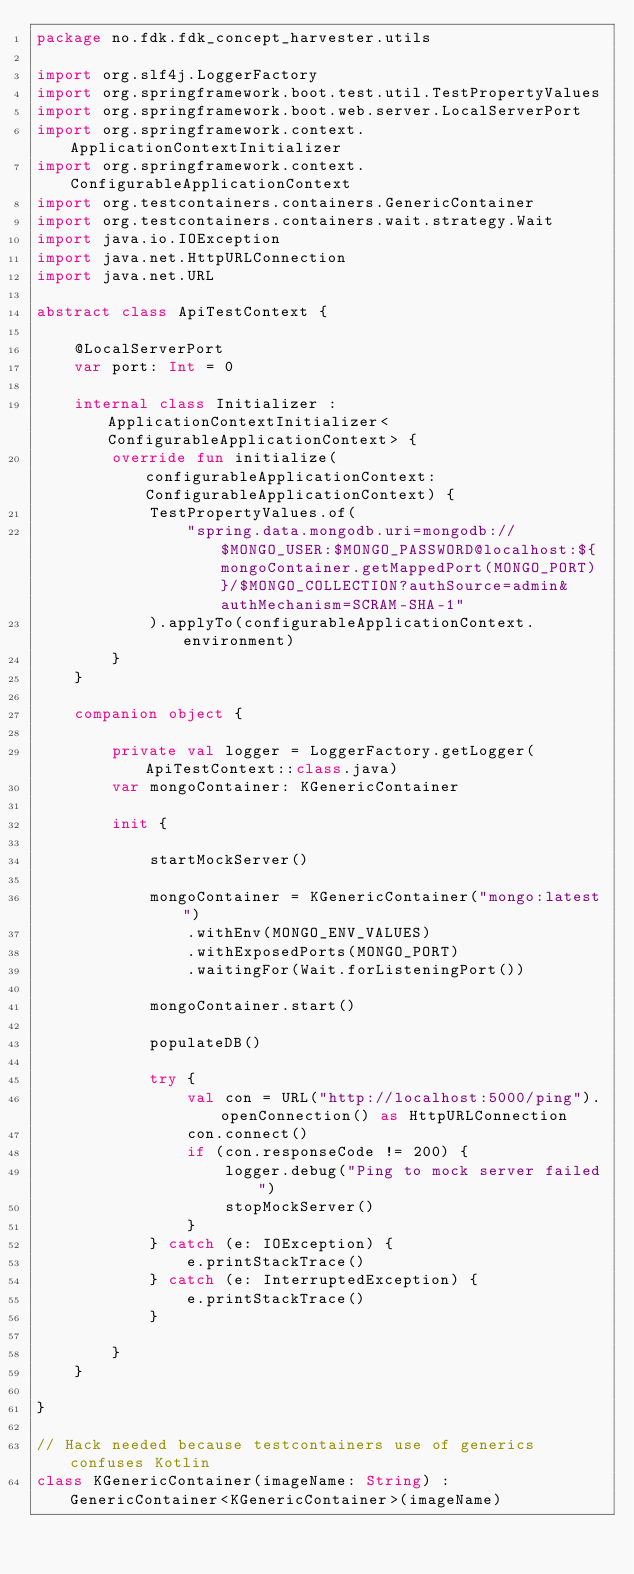Convert code to text. <code><loc_0><loc_0><loc_500><loc_500><_Kotlin_>package no.fdk.fdk_concept_harvester.utils

import org.slf4j.LoggerFactory
import org.springframework.boot.test.util.TestPropertyValues
import org.springframework.boot.web.server.LocalServerPort
import org.springframework.context.ApplicationContextInitializer
import org.springframework.context.ConfigurableApplicationContext
import org.testcontainers.containers.GenericContainer
import org.testcontainers.containers.wait.strategy.Wait
import java.io.IOException
import java.net.HttpURLConnection
import java.net.URL

abstract class ApiTestContext {

    @LocalServerPort
    var port: Int = 0

    internal class Initializer : ApplicationContextInitializer<ConfigurableApplicationContext> {
        override fun initialize(configurableApplicationContext: ConfigurableApplicationContext) {
            TestPropertyValues.of(
                "spring.data.mongodb.uri=mongodb://$MONGO_USER:$MONGO_PASSWORD@localhost:${mongoContainer.getMappedPort(MONGO_PORT)}/$MONGO_COLLECTION?authSource=admin&authMechanism=SCRAM-SHA-1"
            ).applyTo(configurableApplicationContext.environment)
        }
    }

    companion object {

        private val logger = LoggerFactory.getLogger(ApiTestContext::class.java)
        var mongoContainer: KGenericContainer

        init {

            startMockServer()

            mongoContainer = KGenericContainer("mongo:latest")
                .withEnv(MONGO_ENV_VALUES)
                .withExposedPorts(MONGO_PORT)
                .waitingFor(Wait.forListeningPort())

            mongoContainer.start()

            populateDB()

            try {
                val con = URL("http://localhost:5000/ping").openConnection() as HttpURLConnection
                con.connect()
                if (con.responseCode != 200) {
                    logger.debug("Ping to mock server failed")
                    stopMockServer()
                }
            } catch (e: IOException) {
                e.printStackTrace()
            } catch (e: InterruptedException) {
                e.printStackTrace()
            }

        }
    }

}

// Hack needed because testcontainers use of generics confuses Kotlin
class KGenericContainer(imageName: String) : GenericContainer<KGenericContainer>(imageName)
</code> 